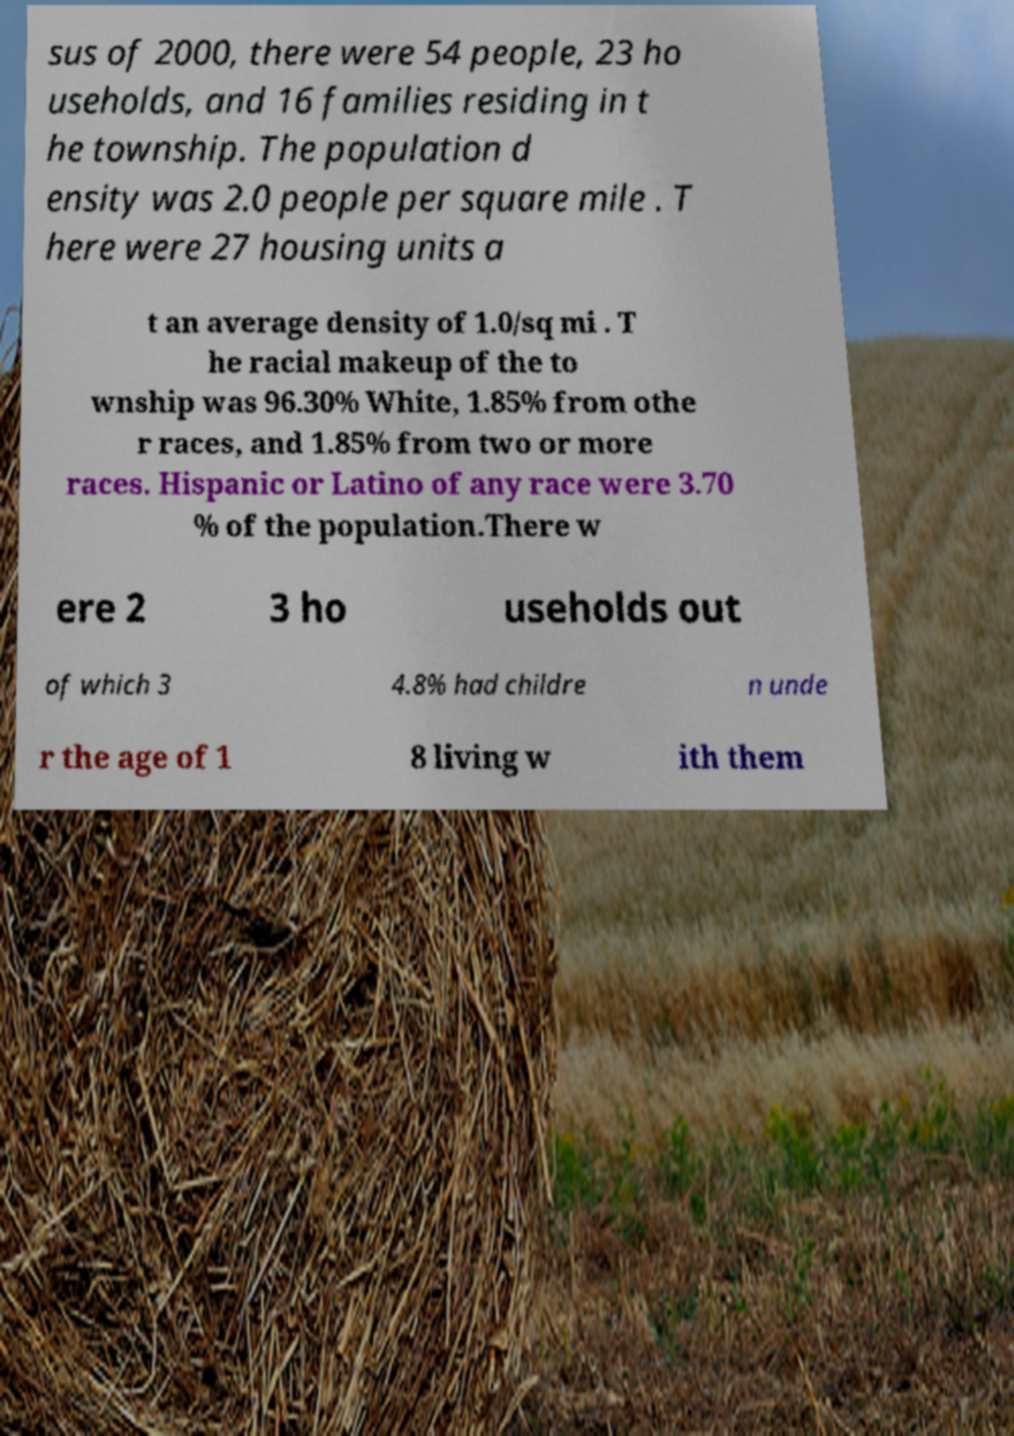There's text embedded in this image that I need extracted. Can you transcribe it verbatim? sus of 2000, there were 54 people, 23 ho useholds, and 16 families residing in t he township. The population d ensity was 2.0 people per square mile . T here were 27 housing units a t an average density of 1.0/sq mi . T he racial makeup of the to wnship was 96.30% White, 1.85% from othe r races, and 1.85% from two or more races. Hispanic or Latino of any race were 3.70 % of the population.There w ere 2 3 ho useholds out of which 3 4.8% had childre n unde r the age of 1 8 living w ith them 